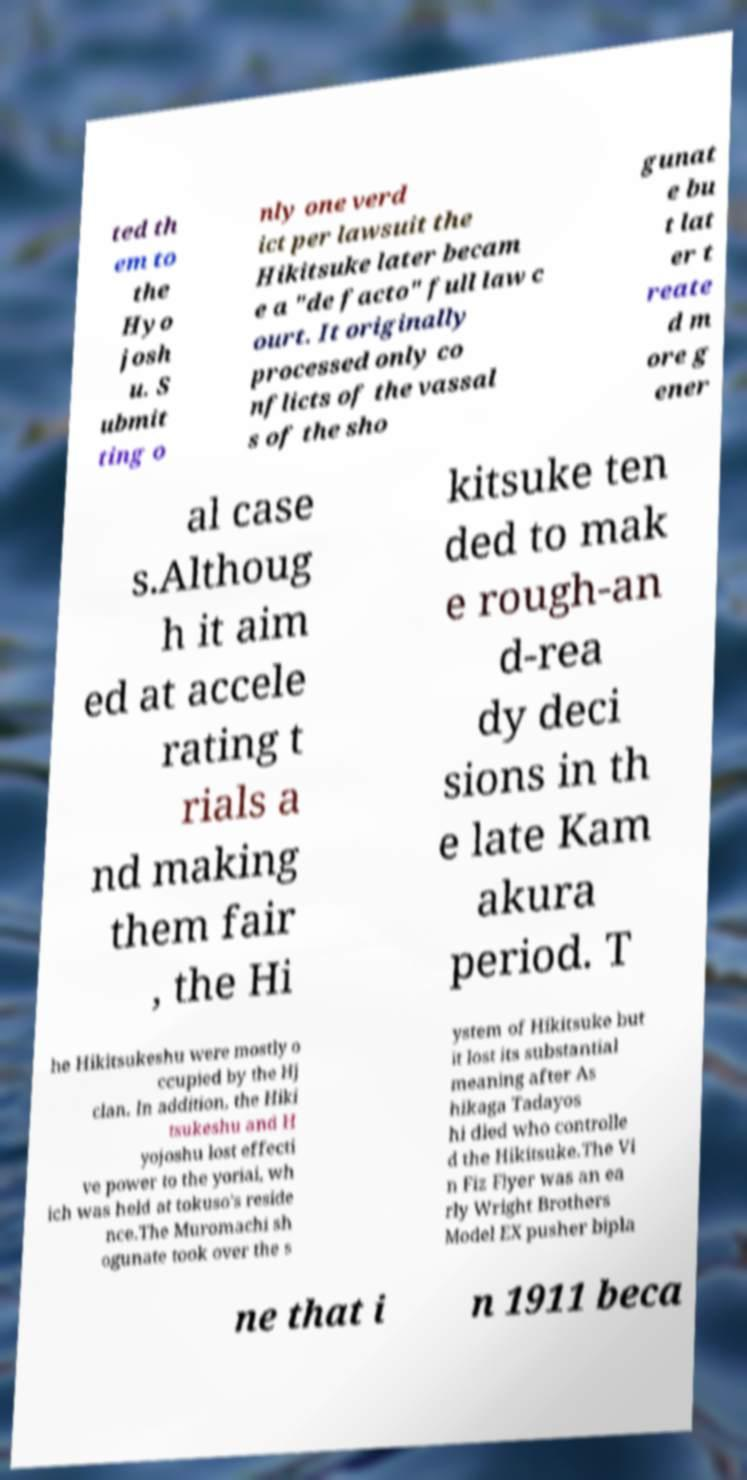Can you read and provide the text displayed in the image?This photo seems to have some interesting text. Can you extract and type it out for me? ted th em to the Hyo josh u. S ubmit ting o nly one verd ict per lawsuit the Hikitsuke later becam e a "de facto" full law c ourt. It originally processed only co nflicts of the vassal s of the sho gunat e bu t lat er t reate d m ore g ener al case s.Althoug h it aim ed at accele rating t rials a nd making them fair , the Hi kitsuke ten ded to mak e rough-an d-rea dy deci sions in th e late Kam akura period. T he Hikitsukeshu were mostly o ccupied by the Hj clan. In addition, the Hiki tsukeshu and H yojoshu lost effecti ve power to the yoriai, wh ich was held at tokuso's reside nce.The Muromachi sh ogunate took over the s ystem of Hikitsuke but it lost its substantial meaning after As hikaga Tadayos hi died who controlle d the Hikitsuke.The Vi n Fiz Flyer was an ea rly Wright Brothers Model EX pusher bipla ne that i n 1911 beca 